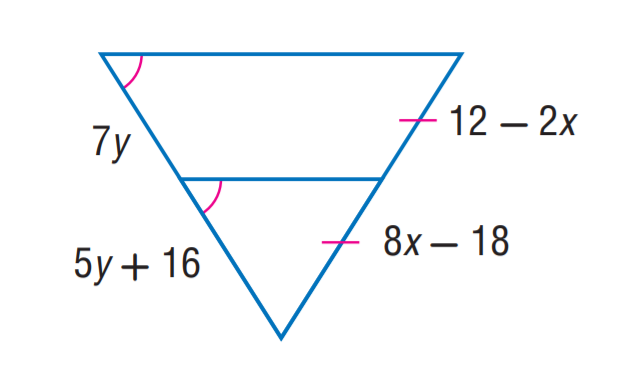Question: Find y.
Choices:
A. 7
B. 8
C. 12
D. 16
Answer with the letter. Answer: B 